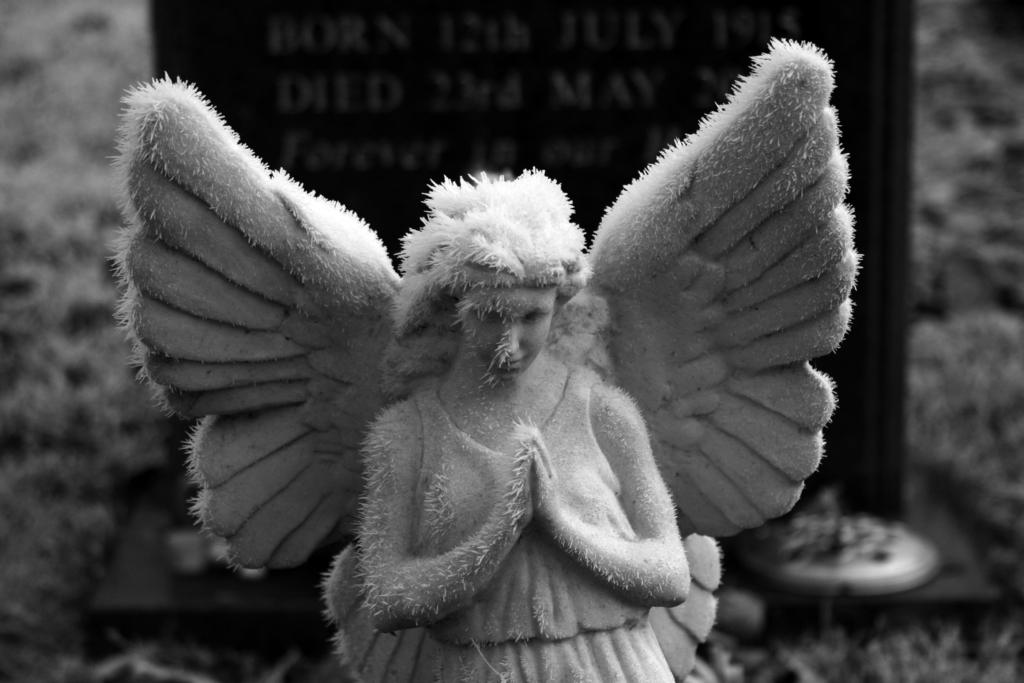What is the color scheme of the image? The image is black and white. What can be seen in the image besides the color scheme? There is a statue in the image. What additional feature is present on the statue? There is a board with text on the backside of the statue. What type of ink is used to write on the quince in the image? There is no quince or ink present in the image; it features a black and white statue with a board on its backside. 